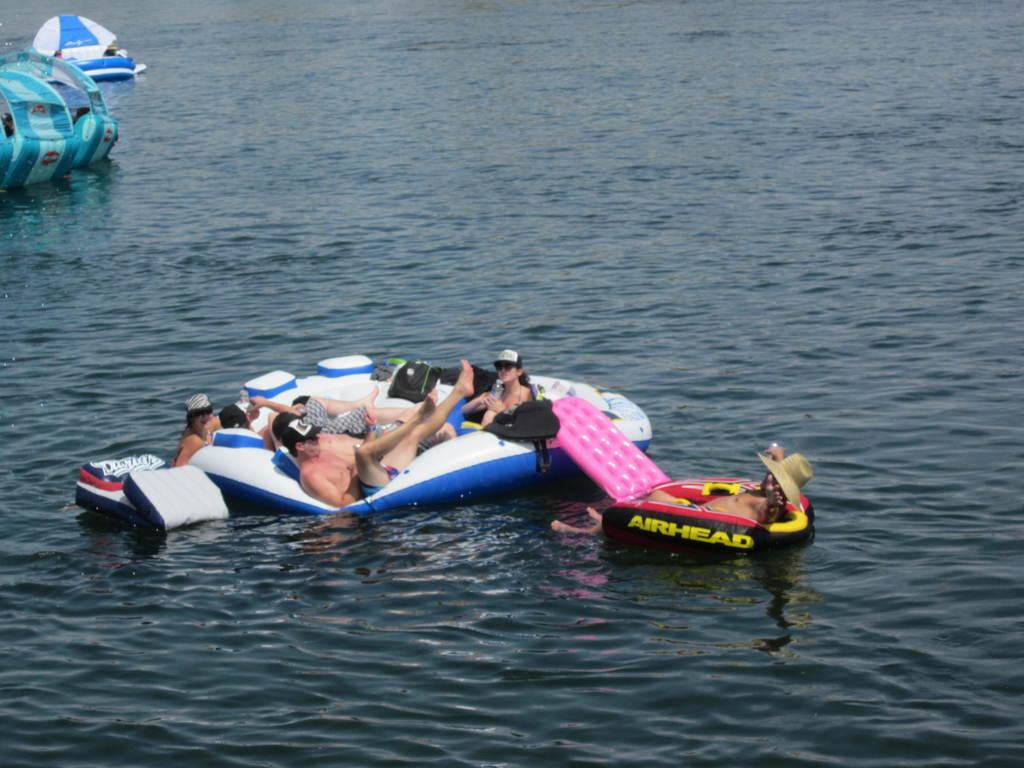Provide a one-sentence caption for the provided image. A woman in a sunhat is laying on an inflatable, airhead raft, next to another, larger raft, with several people inside it. 